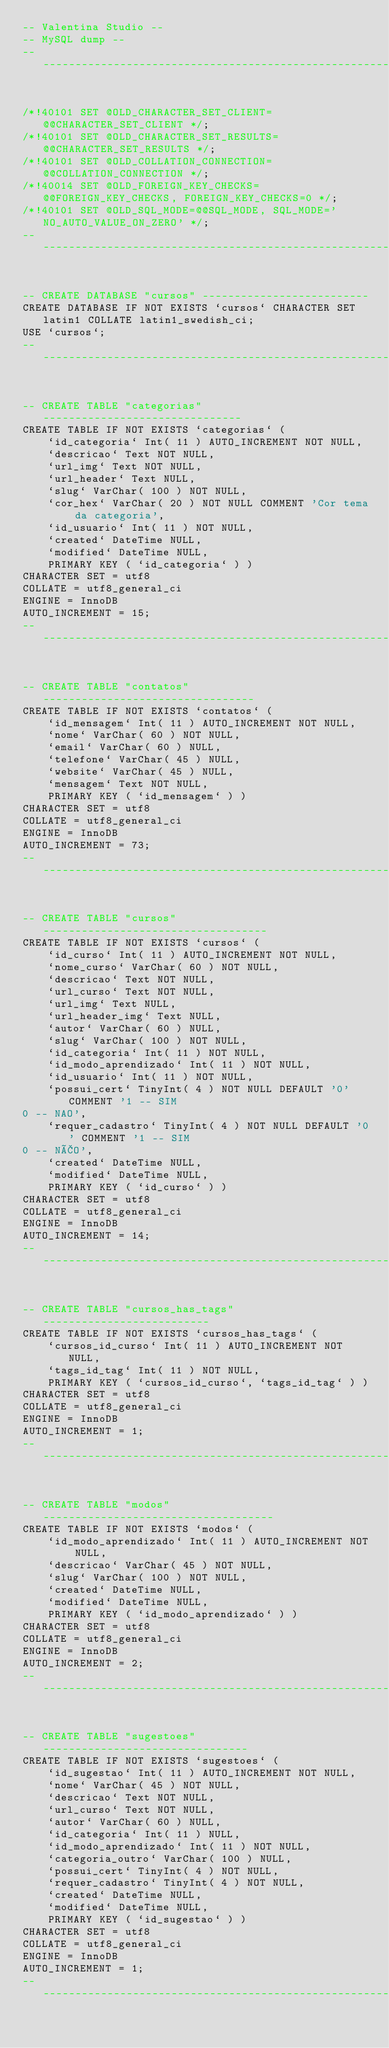<code> <loc_0><loc_0><loc_500><loc_500><_SQL_>-- Valentina Studio --
-- MySQL dump --
-- ---------------------------------------------------------


/*!40101 SET @OLD_CHARACTER_SET_CLIENT=@@CHARACTER_SET_CLIENT */;
/*!40101 SET @OLD_CHARACTER_SET_RESULTS=@@CHARACTER_SET_RESULTS */;
/*!40101 SET @OLD_COLLATION_CONNECTION=@@COLLATION_CONNECTION */;
/*!40014 SET @OLD_FOREIGN_KEY_CHECKS=@@FOREIGN_KEY_CHECKS, FOREIGN_KEY_CHECKS=0 */;
/*!40101 SET @OLD_SQL_MODE=@@SQL_MODE, SQL_MODE='NO_AUTO_VALUE_ON_ZERO' */;
-- ---------------------------------------------------------


-- CREATE DATABASE "cursos" --------------------------
CREATE DATABASE IF NOT EXISTS `cursos` CHARACTER SET latin1 COLLATE latin1_swedish_ci;
USE `cursos`;
-- ---------------------------------------------------------


-- CREATE TABLE "categorias" -------------------------------
CREATE TABLE IF NOT EXISTS `categorias` (
	`id_categoria` Int( 11 ) AUTO_INCREMENT NOT NULL,
	`descricao` Text NOT NULL,
	`url_img` Text NOT NULL,
	`url_header` Text NULL,
	`slug` VarChar( 100 ) NOT NULL,
	`cor_hex` VarChar( 20 ) NOT NULL COMMENT 'Cor tema da categoria',
	`id_usuario` Int( 11 ) NOT NULL,
	`created` DateTime NULL,
	`modified` DateTime NULL,
	PRIMARY KEY ( `id_categoria` ) )
CHARACTER SET = utf8
COLLATE = utf8_general_ci
ENGINE = InnoDB
AUTO_INCREMENT = 15;
-- ---------------------------------------------------------


-- CREATE TABLE "contatos" ---------------------------------
CREATE TABLE IF NOT EXISTS `contatos` (
	`id_mensagem` Int( 11 ) AUTO_INCREMENT NOT NULL,
	`nome` VarChar( 60 ) NOT NULL,
	`email` VarChar( 60 ) NULL,
	`telefone` VarChar( 45 ) NULL,
	`website` VarChar( 45 ) NULL,
	`mensagem` Text NOT NULL,
	PRIMARY KEY ( `id_mensagem` ) )
CHARACTER SET = utf8
COLLATE = utf8_general_ci
ENGINE = InnoDB
AUTO_INCREMENT = 73;
-- ---------------------------------------------------------


-- CREATE TABLE "cursos" -----------------------------------
CREATE TABLE IF NOT EXISTS `cursos` (
	`id_curso` Int( 11 ) AUTO_INCREMENT NOT NULL,
	`nome_curso` VarChar( 60 ) NOT NULL,
	`descricao` Text NOT NULL,
	`url_curso` Text NOT NULL,
	`url_img` Text NULL,
	`url_header_img` Text NULL,
	`autor` VarChar( 60 ) NULL,
	`slug` VarChar( 100 ) NOT NULL,
	`id_categoria` Int( 11 ) NOT NULL,
	`id_modo_aprendizado` Int( 11 ) NOT NULL,
	`id_usuario` Int( 11 ) NOT NULL,
	`possui_cert` TinyInt( 4 ) NOT NULL DEFAULT '0' COMMENT '1 -- SIM
0 -- NAO',
	`requer_cadastro` TinyInt( 4 ) NOT NULL DEFAULT '0' COMMENT '1 -- SIM
0 -- NÃO',
	`created` DateTime NULL,
	`modified` DateTime NULL,
	PRIMARY KEY ( `id_curso` ) )
CHARACTER SET = utf8
COLLATE = utf8_general_ci
ENGINE = InnoDB
AUTO_INCREMENT = 14;
-- ---------------------------------------------------------


-- CREATE TABLE "cursos_has_tags" --------------------------
CREATE TABLE IF NOT EXISTS `cursos_has_tags` (
	`cursos_id_curso` Int( 11 ) AUTO_INCREMENT NOT NULL,
	`tags_id_tag` Int( 11 ) NOT NULL,
	PRIMARY KEY ( `cursos_id_curso`, `tags_id_tag` ) )
CHARACTER SET = utf8
COLLATE = utf8_general_ci
ENGINE = InnoDB
AUTO_INCREMENT = 1;
-- ---------------------------------------------------------


-- CREATE TABLE "modos" ------------------------------------
CREATE TABLE IF NOT EXISTS `modos` (
	`id_modo_aprendizado` Int( 11 ) AUTO_INCREMENT NOT NULL,
	`descricao` VarChar( 45 ) NOT NULL,
	`slug` VarChar( 100 ) NOT NULL,
	`created` DateTime NULL,
	`modified` DateTime NULL,
	PRIMARY KEY ( `id_modo_aprendizado` ) )
CHARACTER SET = utf8
COLLATE = utf8_general_ci
ENGINE = InnoDB
AUTO_INCREMENT = 2;
-- ---------------------------------------------------------


-- CREATE TABLE "sugestoes" --------------------------------
CREATE TABLE IF NOT EXISTS `sugestoes` (
	`id_sugestao` Int( 11 ) AUTO_INCREMENT NOT NULL,
	`nome` VarChar( 45 ) NOT NULL,
	`descricao` Text NOT NULL,
	`url_curso` Text NOT NULL,
	`autor` VarChar( 60 ) NULL,
	`id_categoria` Int( 11 ) NULL,
	`id_modo_aprendizado` Int( 11 ) NOT NULL,
	`categoria_outro` VarChar( 100 ) NULL,
	`possui_cert` TinyInt( 4 ) NOT NULL,
	`requer_cadastro` TinyInt( 4 ) NOT NULL,
	`created` DateTime NULL,
	`modified` DateTime NULL,
	PRIMARY KEY ( `id_sugestao` ) )
CHARACTER SET = utf8
COLLATE = utf8_general_ci
ENGINE = InnoDB
AUTO_INCREMENT = 1;
-- ---------------------------------------------------------

</code> 